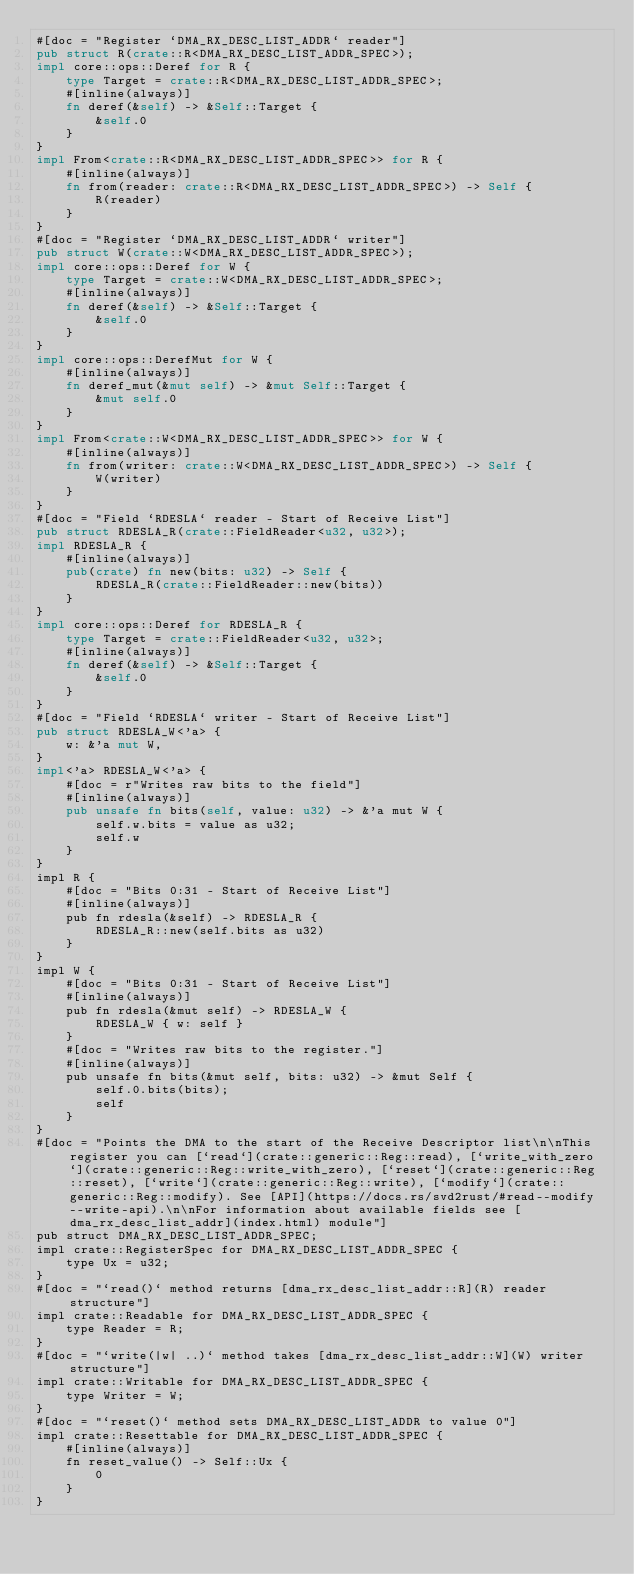Convert code to text. <code><loc_0><loc_0><loc_500><loc_500><_Rust_>#[doc = "Register `DMA_RX_DESC_LIST_ADDR` reader"]
pub struct R(crate::R<DMA_RX_DESC_LIST_ADDR_SPEC>);
impl core::ops::Deref for R {
    type Target = crate::R<DMA_RX_DESC_LIST_ADDR_SPEC>;
    #[inline(always)]
    fn deref(&self) -> &Self::Target {
        &self.0
    }
}
impl From<crate::R<DMA_RX_DESC_LIST_ADDR_SPEC>> for R {
    #[inline(always)]
    fn from(reader: crate::R<DMA_RX_DESC_LIST_ADDR_SPEC>) -> Self {
        R(reader)
    }
}
#[doc = "Register `DMA_RX_DESC_LIST_ADDR` writer"]
pub struct W(crate::W<DMA_RX_DESC_LIST_ADDR_SPEC>);
impl core::ops::Deref for W {
    type Target = crate::W<DMA_RX_DESC_LIST_ADDR_SPEC>;
    #[inline(always)]
    fn deref(&self) -> &Self::Target {
        &self.0
    }
}
impl core::ops::DerefMut for W {
    #[inline(always)]
    fn deref_mut(&mut self) -> &mut Self::Target {
        &mut self.0
    }
}
impl From<crate::W<DMA_RX_DESC_LIST_ADDR_SPEC>> for W {
    #[inline(always)]
    fn from(writer: crate::W<DMA_RX_DESC_LIST_ADDR_SPEC>) -> Self {
        W(writer)
    }
}
#[doc = "Field `RDESLA` reader - Start of Receive List"]
pub struct RDESLA_R(crate::FieldReader<u32, u32>);
impl RDESLA_R {
    #[inline(always)]
    pub(crate) fn new(bits: u32) -> Self {
        RDESLA_R(crate::FieldReader::new(bits))
    }
}
impl core::ops::Deref for RDESLA_R {
    type Target = crate::FieldReader<u32, u32>;
    #[inline(always)]
    fn deref(&self) -> &Self::Target {
        &self.0
    }
}
#[doc = "Field `RDESLA` writer - Start of Receive List"]
pub struct RDESLA_W<'a> {
    w: &'a mut W,
}
impl<'a> RDESLA_W<'a> {
    #[doc = r"Writes raw bits to the field"]
    #[inline(always)]
    pub unsafe fn bits(self, value: u32) -> &'a mut W {
        self.w.bits = value as u32;
        self.w
    }
}
impl R {
    #[doc = "Bits 0:31 - Start of Receive List"]
    #[inline(always)]
    pub fn rdesla(&self) -> RDESLA_R {
        RDESLA_R::new(self.bits as u32)
    }
}
impl W {
    #[doc = "Bits 0:31 - Start of Receive List"]
    #[inline(always)]
    pub fn rdesla(&mut self) -> RDESLA_W {
        RDESLA_W { w: self }
    }
    #[doc = "Writes raw bits to the register."]
    #[inline(always)]
    pub unsafe fn bits(&mut self, bits: u32) -> &mut Self {
        self.0.bits(bits);
        self
    }
}
#[doc = "Points the DMA to the start of the Receive Descriptor list\n\nThis register you can [`read`](crate::generic::Reg::read), [`write_with_zero`](crate::generic::Reg::write_with_zero), [`reset`](crate::generic::Reg::reset), [`write`](crate::generic::Reg::write), [`modify`](crate::generic::Reg::modify). See [API](https://docs.rs/svd2rust/#read--modify--write-api).\n\nFor information about available fields see [dma_rx_desc_list_addr](index.html) module"]
pub struct DMA_RX_DESC_LIST_ADDR_SPEC;
impl crate::RegisterSpec for DMA_RX_DESC_LIST_ADDR_SPEC {
    type Ux = u32;
}
#[doc = "`read()` method returns [dma_rx_desc_list_addr::R](R) reader structure"]
impl crate::Readable for DMA_RX_DESC_LIST_ADDR_SPEC {
    type Reader = R;
}
#[doc = "`write(|w| ..)` method takes [dma_rx_desc_list_addr::W](W) writer structure"]
impl crate::Writable for DMA_RX_DESC_LIST_ADDR_SPEC {
    type Writer = W;
}
#[doc = "`reset()` method sets DMA_RX_DESC_LIST_ADDR to value 0"]
impl crate::Resettable for DMA_RX_DESC_LIST_ADDR_SPEC {
    #[inline(always)]
    fn reset_value() -> Self::Ux {
        0
    }
}
</code> 